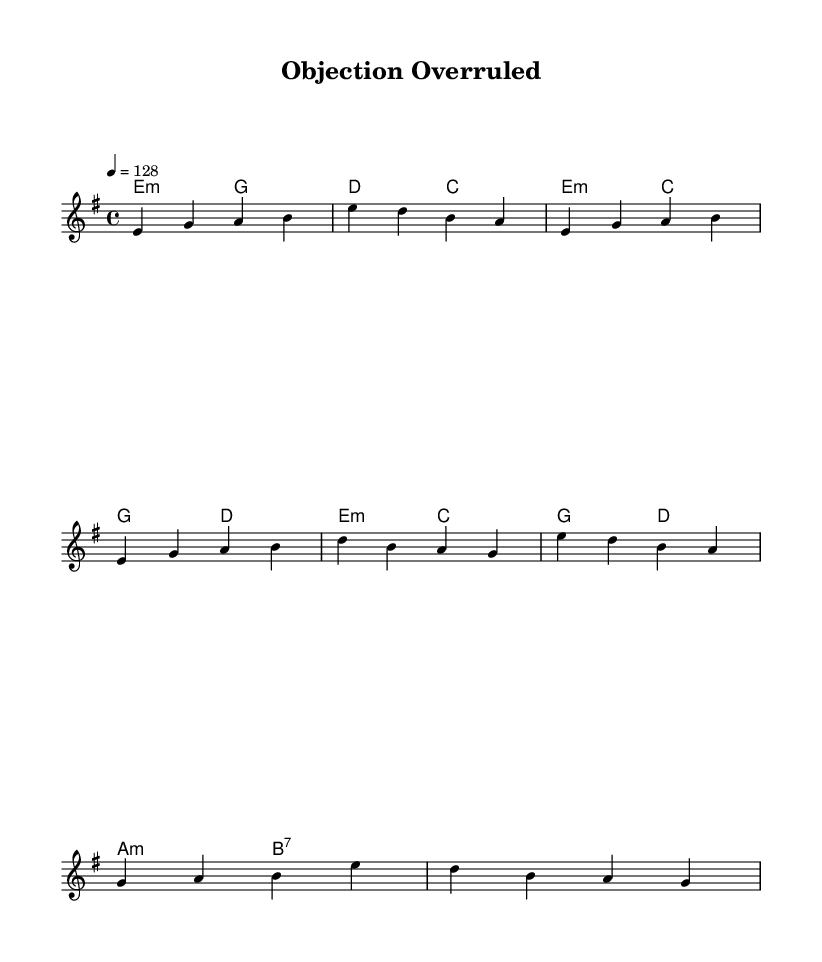What is the key signature of this music? The key signature shows that there are no sharps or flats, which indicates the key is E minor.
Answer: E minor What is the time signature of this music? The time signature is indicated by the fraction at the beginning of the sheet music, which shows that there are 4 beats per measure and a quarter note gets one beat.
Answer: 4/4 What is the tempo marking for the piece? The tempo marking is indicated by "4 = 128," which means there are 128 beats per minute.
Answer: 128 How many bars are in the chorus section? By examining the sheet music, we can see that there are 4 measures represented in the chorus section.
Answer: 4 What is the main theme of the lyrics in this piece? The lyrics suggest a courtroom setting and discuss themes related to justice and rulings in court, as reflected in phrases like "Objection overruled."
Answer: Justice Which chord is used in the chorus? Looking at the harmonic section above the melody, we find that the chorus contains the chords E minor and C major, which are clear in the musical structure.
Answer: E minor and C major What is the overall mood conveyed by the music based on the chords used? The combination of minor chords, such as E minor and A minor present in the song, typically conveys a serious or dramatic mood, aligning with themes of courtroom drama.
Answer: Serious 